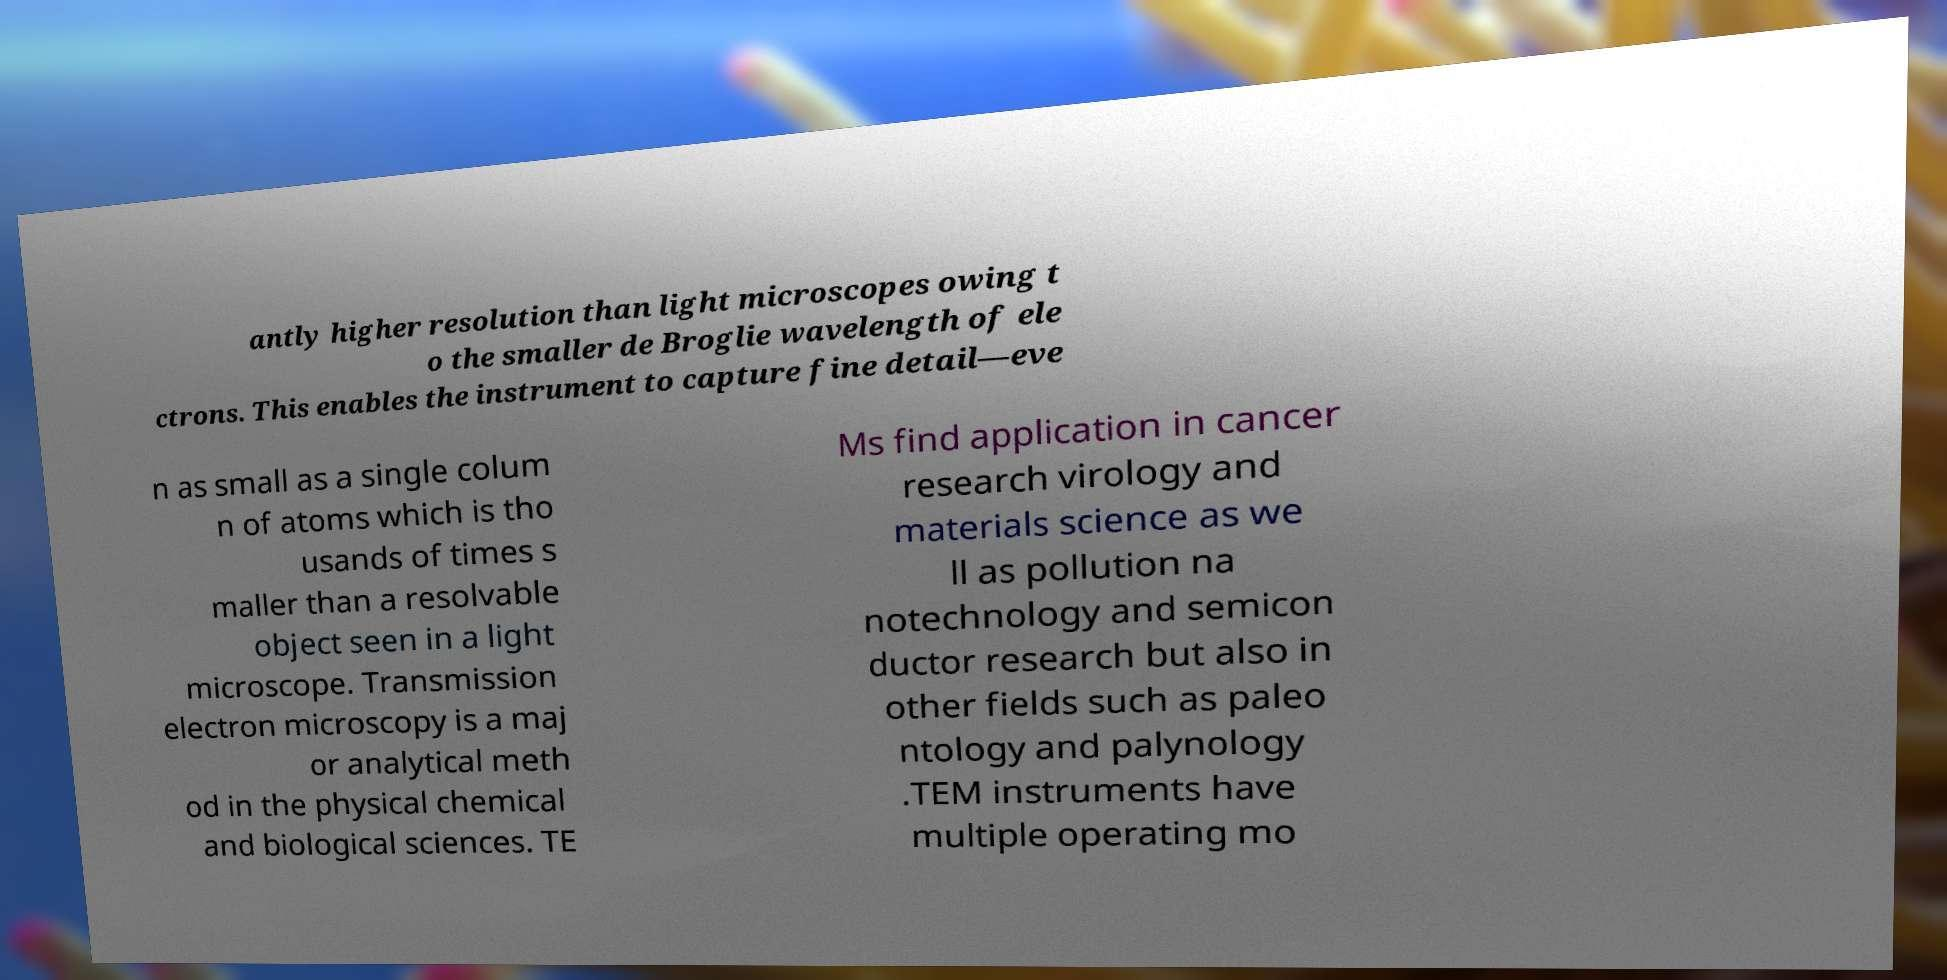Please read and relay the text visible in this image. What does it say? antly higher resolution than light microscopes owing t o the smaller de Broglie wavelength of ele ctrons. This enables the instrument to capture fine detail—eve n as small as a single colum n of atoms which is tho usands of times s maller than a resolvable object seen in a light microscope. Transmission electron microscopy is a maj or analytical meth od in the physical chemical and biological sciences. TE Ms find application in cancer research virology and materials science as we ll as pollution na notechnology and semicon ductor research but also in other fields such as paleo ntology and palynology .TEM instruments have multiple operating mo 